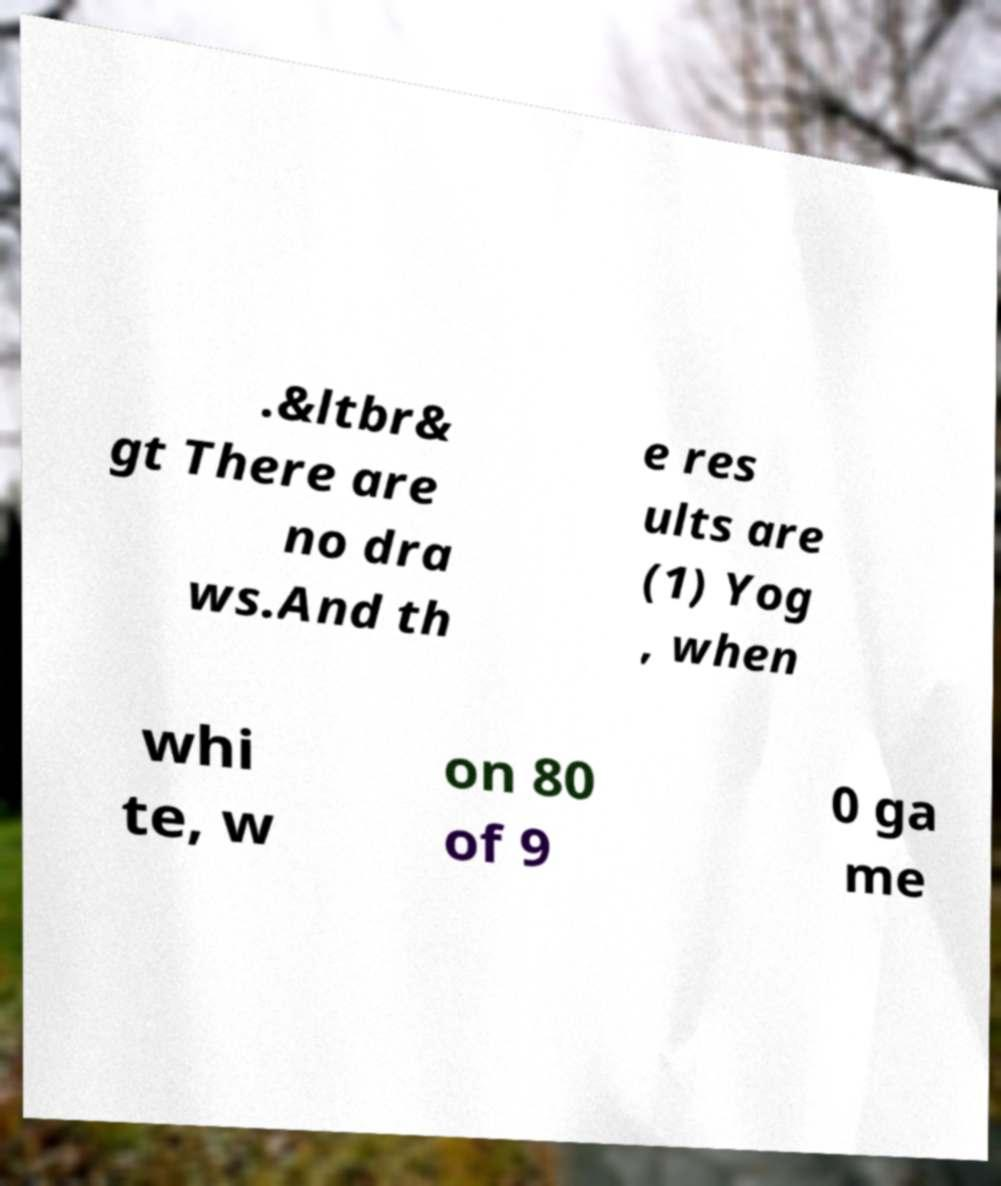Could you assist in decoding the text presented in this image and type it out clearly? .&ltbr& gt There are no dra ws.And th e res ults are (1) Yog , when whi te, w on 80 of 9 0 ga me 